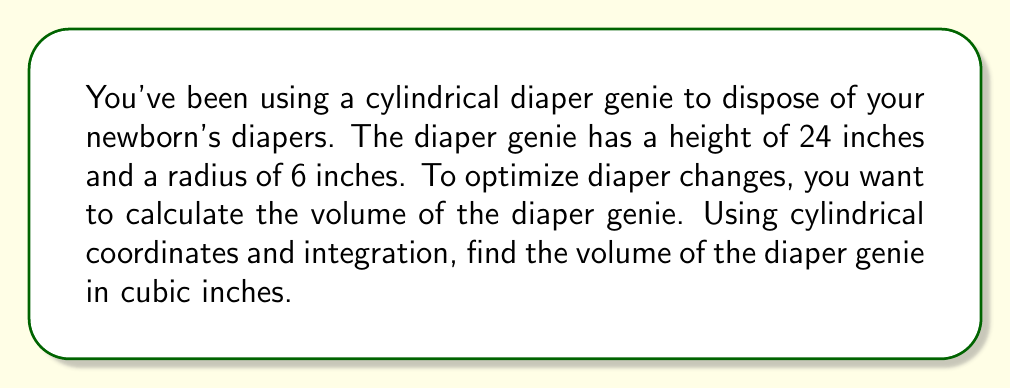Teach me how to tackle this problem. To find the volume of the cylindrical diaper genie using cylindrical coordinates and integration, we'll follow these steps:

1) In cylindrical coordinates, we have:
   $r$ (radius), $\theta$ (angle), and $z$ (height)

2) The volume integral in cylindrical coordinates is given by:
   $$V = \int_0^h \int_0^{2\pi} \int_0^R r \, dr \, d\theta \, dz$$
   where $h$ is the height and $R$ is the radius of the cylinder.

3) For our diaper genie:
   $h = 24$ inches
   $R = 6$ inches

4) Let's set up the integral:
   $$V = \int_0^{24} \int_0^{2\pi} \int_0^6 r \, dr \, d\theta \, dz$$

5) Integrate with respect to $r$:
   $$V = \int_0^{24} \int_0^{2\pi} \left[\frac{r^2}{2}\right]_0^6 \, d\theta \, dz$$
   $$V = \int_0^{24} \int_0^{2\pi} 18 \, d\theta \, dz$$

6) Integrate with respect to $\theta$:
   $$V = \int_0^{24} [18\theta]_0^{2\pi} \, dz$$
   $$V = \int_0^{24} 36\pi \, dz$$

7) Finally, integrate with respect to $z$:
   $$V = [36\pi z]_0^{24}$$
   $$V = 36\pi(24) - 36\pi(0) = 864\pi$$

Therefore, the volume of the diaper genie is $864\pi$ cubic inches.
Answer: $864\pi$ cubic inches 